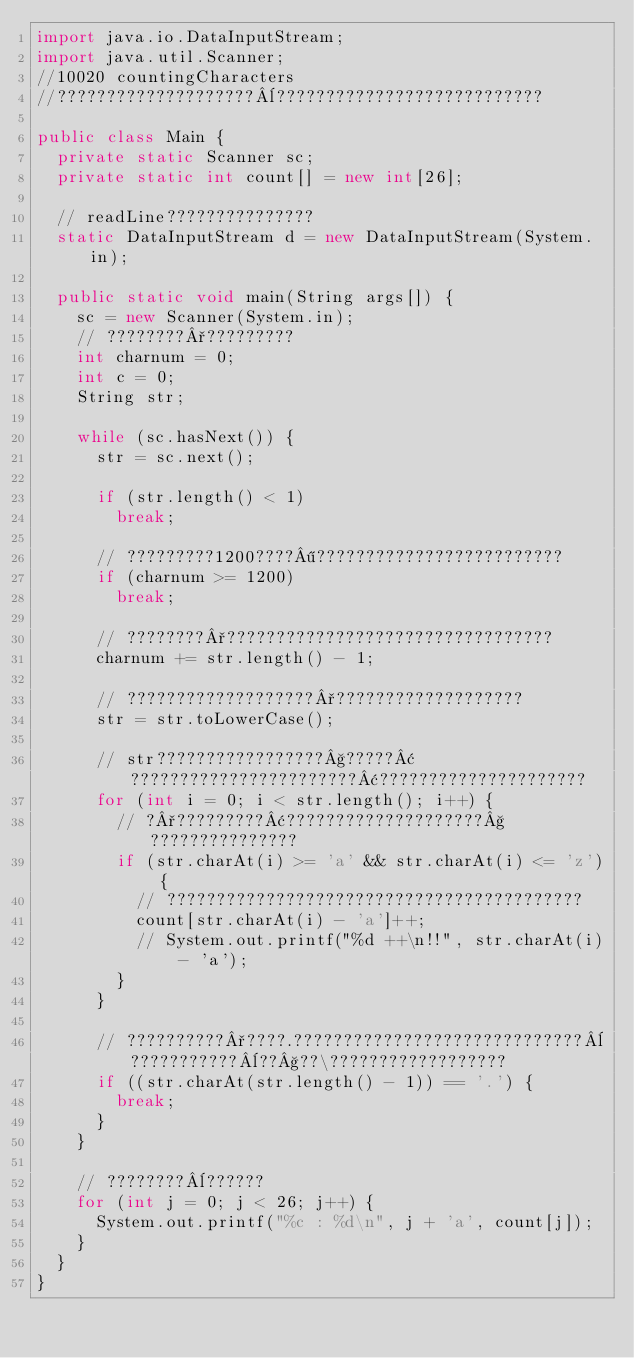<code> <loc_0><loc_0><loc_500><loc_500><_Java_>import java.io.DataInputStream;
import java.util.Scanner;
//10020 countingCharacters
//????????????????????¨???????????????????????????

public class Main {
	private static Scanner sc;
	private static int count[] = new int[26];

	// readLine???????????????
	static DataInputStream d = new DataInputStream(System.in);

	public static void main(String args[]) {
		sc = new Scanner(System.in);
		// ????????°?????????
		int charnum = 0;
		int c = 0;
		String str;

		while (sc.hasNext()) {
			str = sc.next();

			if (str.length() < 1)
				break;

			// ?????????1200????¶?????????????????????????
			if (charnum >= 1200)
				break;

			// ????????°?????????????????????????????????
			charnum += str.length() - 1;

			// ???????????????????°???????????????????
			str = str.toLowerCase();

			// str?????????????????§?????¢???????????????????????¢?????????????????????
			for (int i = 0; i < str.length(); i++) {
				// ?°?????????¢????????????????????§???????????????
				if (str.charAt(i) >= 'a' && str.charAt(i) <= 'z') {
					// ??????????????????????????????????????????
					count[str.charAt(i) - 'a']++;
					// System.out.printf("%d ++\n!!", str.charAt(i) - 'a');
				}
			}

			// ??????????°????.?????????????????????????????¨???????????¨??§??\??????????????????
			if ((str.charAt(str.length() - 1)) == '.') {
				break;
			}
		}

		// ????????¨??????
		for (int j = 0; j < 26; j++) {
			System.out.printf("%c : %d\n", j + 'a', count[j]);
		}
	}
}</code> 